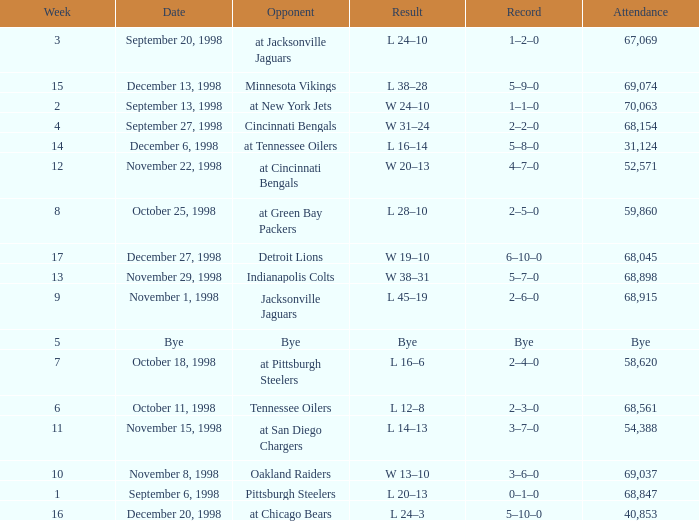Parse the table in full. {'header': ['Week', 'Date', 'Opponent', 'Result', 'Record', 'Attendance'], 'rows': [['3', 'September 20, 1998', 'at Jacksonville Jaguars', 'L 24–10', '1–2–0', '67,069'], ['15', 'December 13, 1998', 'Minnesota Vikings', 'L 38–28', '5–9–0', '69,074'], ['2', 'September 13, 1998', 'at New York Jets', 'W 24–10', '1–1–0', '70,063'], ['4', 'September 27, 1998', 'Cincinnati Bengals', 'W 31–24', '2–2–0', '68,154'], ['14', 'December 6, 1998', 'at Tennessee Oilers', 'L 16–14', '5–8–0', '31,124'], ['12', 'November 22, 1998', 'at Cincinnati Bengals', 'W 20–13', '4–7–0', '52,571'], ['8', 'October 25, 1998', 'at Green Bay Packers', 'L 28–10', '2–5–0', '59,860'], ['17', 'December 27, 1998', 'Detroit Lions', 'W 19–10', '6–10–0', '68,045'], ['13', 'November 29, 1998', 'Indianapolis Colts', 'W 38–31', '5–7–0', '68,898'], ['9', 'November 1, 1998', 'Jacksonville Jaguars', 'L 45–19', '2–6–0', '68,915'], ['5', 'Bye', 'Bye', 'Bye', 'Bye', 'Bye'], ['7', 'October 18, 1998', 'at Pittsburgh Steelers', 'L 16–6', '2–4–0', '58,620'], ['6', 'October 11, 1998', 'Tennessee Oilers', 'L 12–8', '2–3–0', '68,561'], ['11', 'November 15, 1998', 'at San Diego Chargers', 'L 14–13', '3–7–0', '54,388'], ['10', 'November 8, 1998', 'Oakland Raiders', 'W 13–10', '3–6–0', '69,037'], ['1', 'September 6, 1998', 'Pittsburgh Steelers', 'L 20–13', '0–1–0', '68,847'], ['16', 'December 20, 1998', 'at Chicago Bears', 'L 24–3', '5–10–0', '40,853']]} What is the highest week that was played against the Minnesota Vikings? 15.0. 